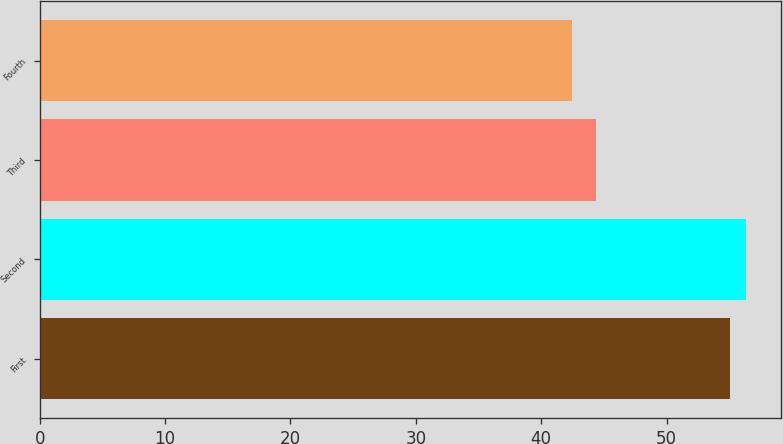Convert chart to OTSL. <chart><loc_0><loc_0><loc_500><loc_500><bar_chart><fcel>First<fcel>Second<fcel>Third<fcel>Fourth<nl><fcel>55.03<fcel>56.32<fcel>44.4<fcel>42.45<nl></chart> 